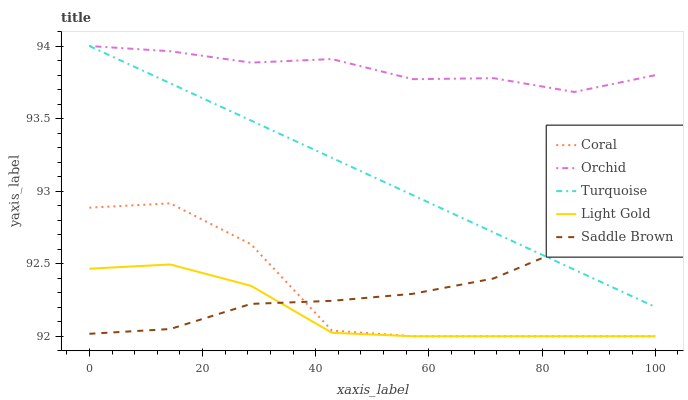Does Light Gold have the minimum area under the curve?
Answer yes or no. Yes. Does Orchid have the maximum area under the curve?
Answer yes or no. Yes. Does Coral have the minimum area under the curve?
Answer yes or no. No. Does Coral have the maximum area under the curve?
Answer yes or no. No. Is Turquoise the smoothest?
Answer yes or no. Yes. Is Coral the roughest?
Answer yes or no. Yes. Is Light Gold the smoothest?
Answer yes or no. No. Is Light Gold the roughest?
Answer yes or no. No. Does Coral have the lowest value?
Answer yes or no. Yes. Does Turquoise have the lowest value?
Answer yes or no. No. Does Orchid have the highest value?
Answer yes or no. Yes. Does Coral have the highest value?
Answer yes or no. No. Is Light Gold less than Turquoise?
Answer yes or no. Yes. Is Turquoise greater than Coral?
Answer yes or no. Yes. Does Saddle Brown intersect Coral?
Answer yes or no. Yes. Is Saddle Brown less than Coral?
Answer yes or no. No. Is Saddle Brown greater than Coral?
Answer yes or no. No. Does Light Gold intersect Turquoise?
Answer yes or no. No. 